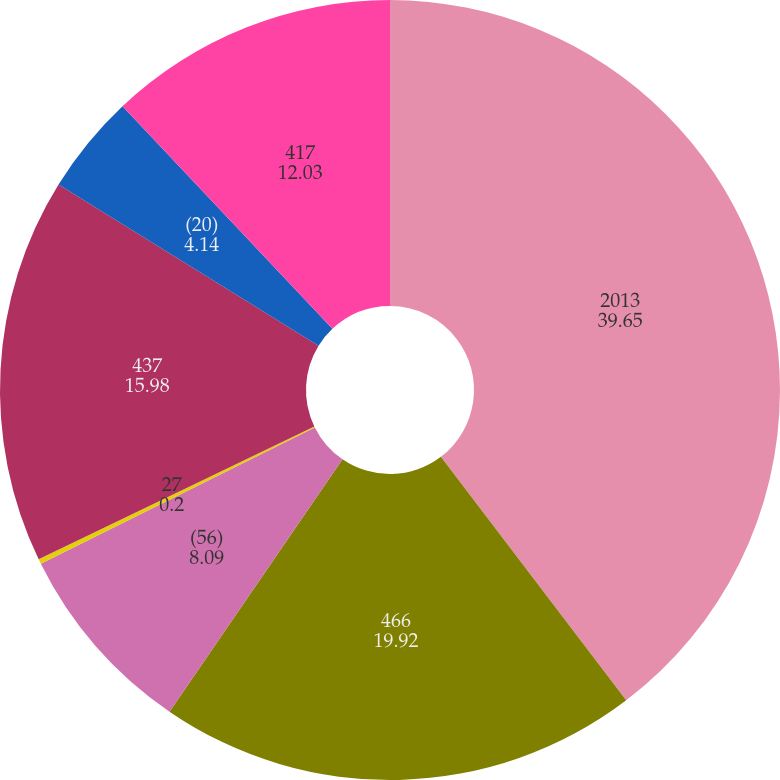Convert chart to OTSL. <chart><loc_0><loc_0><loc_500><loc_500><pie_chart><fcel>2013<fcel>466<fcel>(56)<fcel>27<fcel>437<fcel>(20)<fcel>417<nl><fcel>39.65%<fcel>19.92%<fcel>8.09%<fcel>0.2%<fcel>15.98%<fcel>4.14%<fcel>12.03%<nl></chart> 